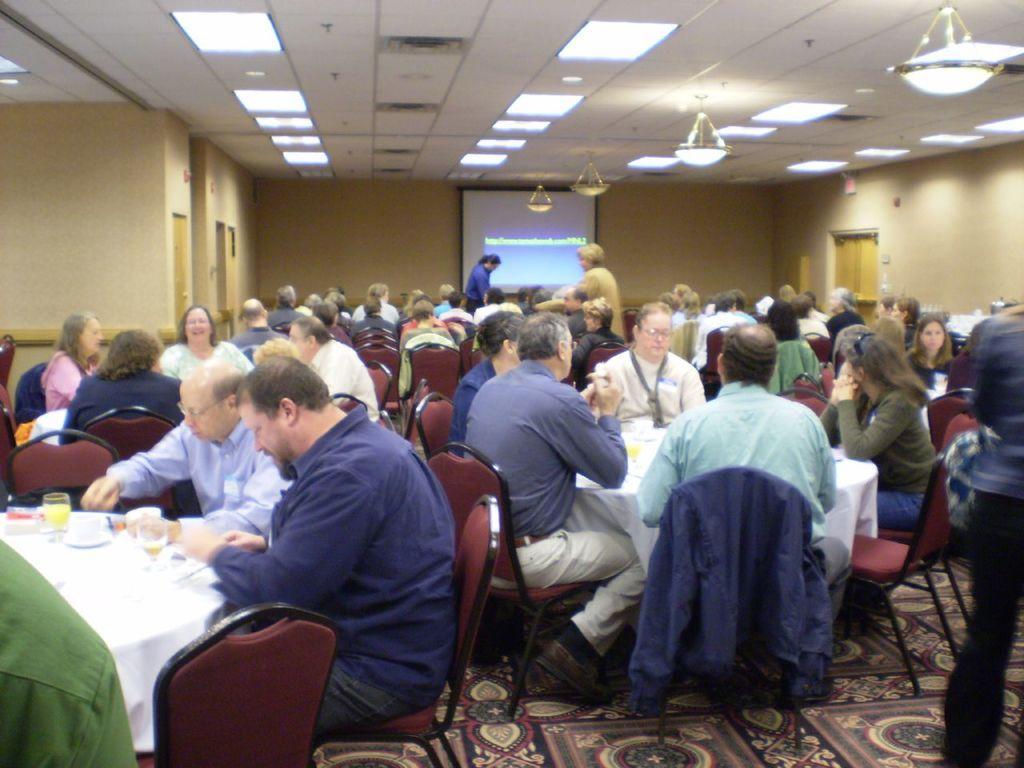Please provide a concise description of this image. In this image we can see many people. There are many chairs and tables in the image. There are many objects placed on the tables. There is a projector screen in the image. There are many lights in the image. 